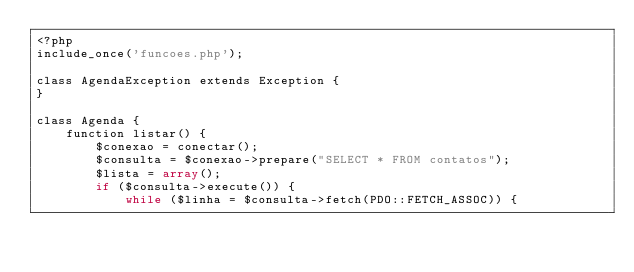<code> <loc_0><loc_0><loc_500><loc_500><_PHP_><?php
include_once('funcoes.php');

class AgendaException extends Exception {
}

class Agenda {
    function listar() {
        $conexao = conectar();
        $consulta = $conexao->prepare("SELECT * FROM contatos");
        $lista = array();
        if ($consulta->execute()) {
            while ($linha = $consulta->fetch(PDO::FETCH_ASSOC)) {</code> 